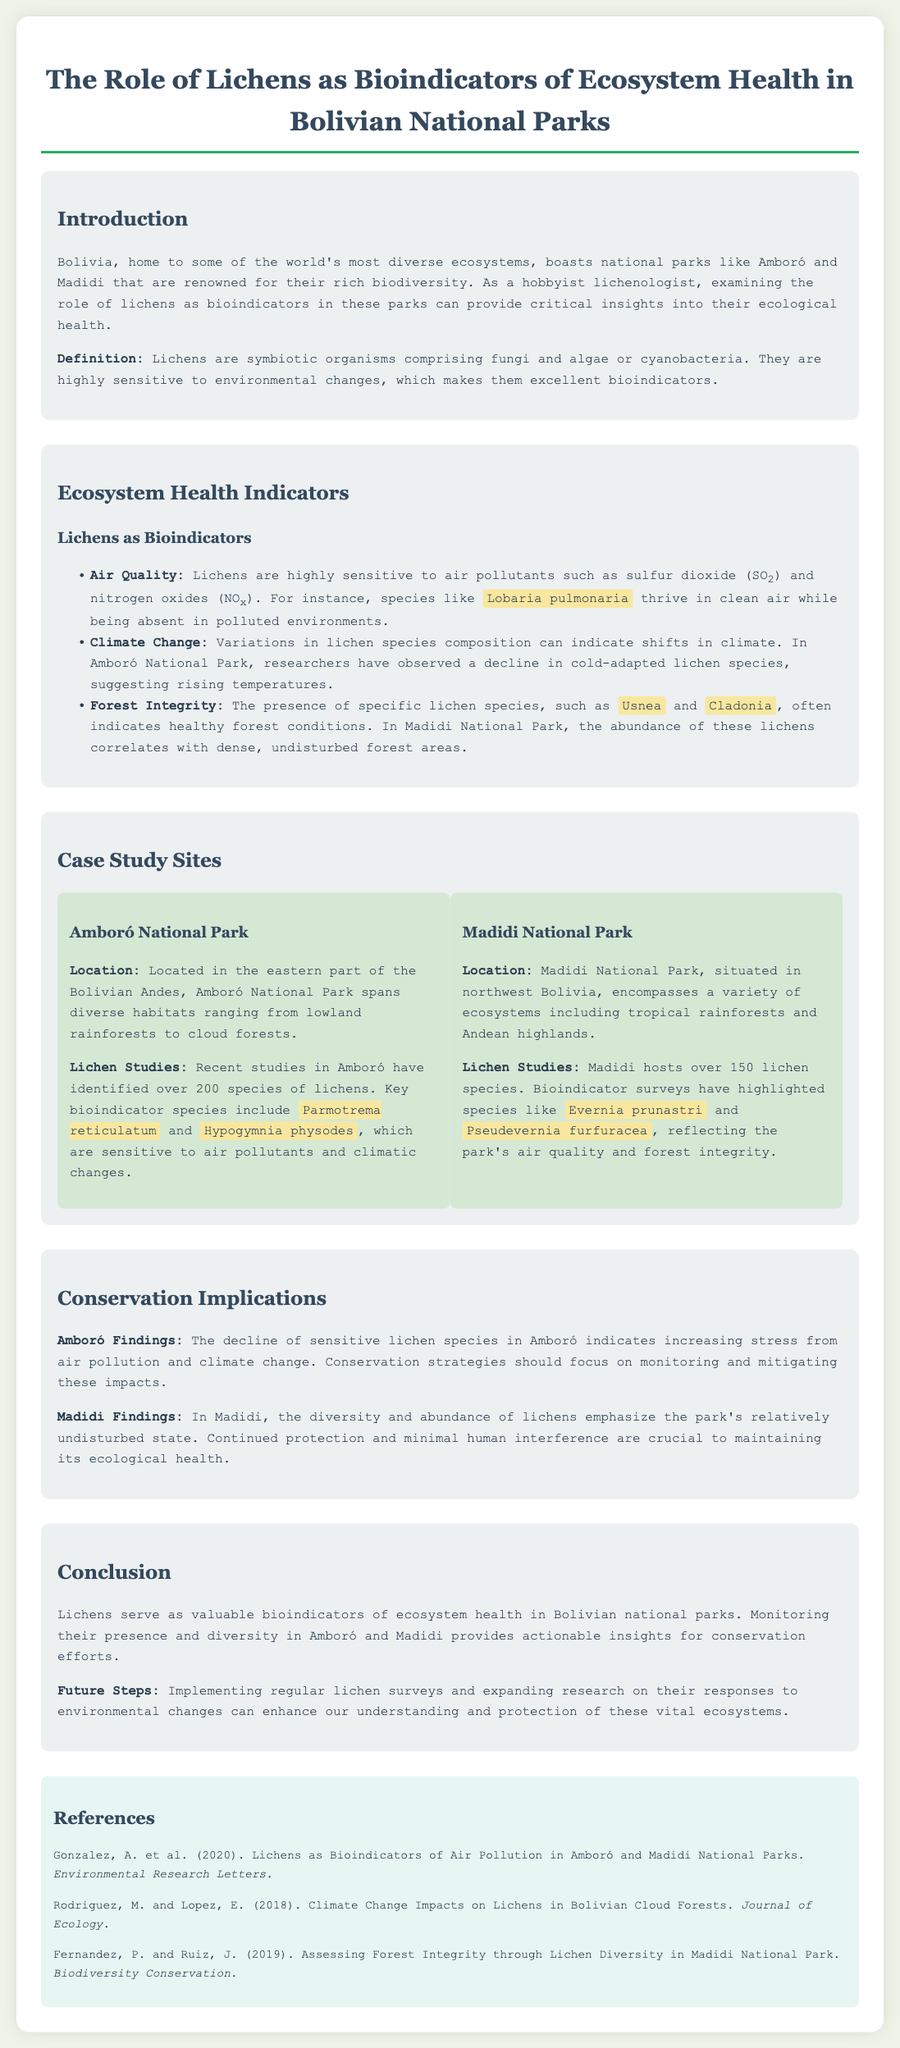what is the name of the first national park mentioned? The first national park mentioned is Amboró National Park.
Answer: Amboró National Park how many lichen species have been identified in Amboró National Park? Over 200 species of lichens have been identified in Amboró.
Answer: over 200 which lichen species is highlighted as thriving in clean air? The lichen species highlighted is Lobaria pulmonaria.
Answer: Lobaria pulmonaria what are the main types of ecosystems found in Madidi National Park? The main types of ecosystems in Madidi National Park include tropical rainforests and Andean highlands.
Answer: tropical rainforests and Andean highlands what does the decline of sensitive lichen species in Amboró indicate? The decline indicates increasing stress from air pollution and climate change.
Answer: increasing stress from air pollution and climate change which lichen species are noted to indicate healthy forest conditions? The lichen species noted to indicate healthy forest conditions are Usnea and Cladonia.
Answer: Usnea and Cladonia what is the total number of lichen species hosted by Madidi National Park? Madidi hosts over 150 lichen species.
Answer: over 150 what should conservation strategies in Amboró focus on? Conservation strategies should focus on monitoring and mitigating impacts from pollution and climate change.
Answer: monitoring and mitigating impacts from pollution and climate change 